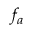<formula> <loc_0><loc_0><loc_500><loc_500>f _ { a }</formula> 